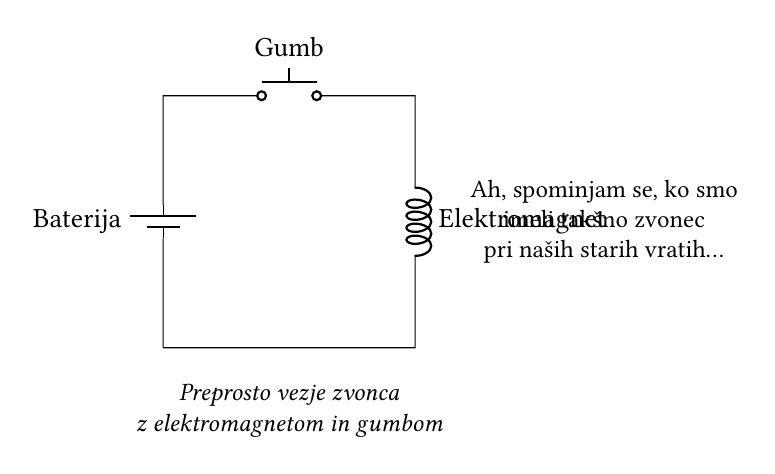What type of switch is used in this circuit? The circuit uses a push-button switch, as indicated by the label near the component in the diagram.
Answer: push-button What component creates the sound in this doorbell circuit? The electromagnetic solenoid acts as the sound-making device by moving when electric current passes through it.
Answer: electromagnetic solenoid What is the main power source for this circuit? The circuit is powered by a battery, as shown by the representation of a battery in the diagram.
Answer: battery How many components are connected in this circuit? There are three components connected in series: a battery, a push-button, and an electromagnetic solenoid.
Answer: three What happens when the push-button is pressed? Pressing the push-button completes the circuit, allowing current to flow from the battery to the electromagnetic solenoid, causing it to activate.
Answer: activate What type of circuit is this considered? This is a simple series circuit, where all components are connected end-to-end and share the same current.
Answer: series circuit 